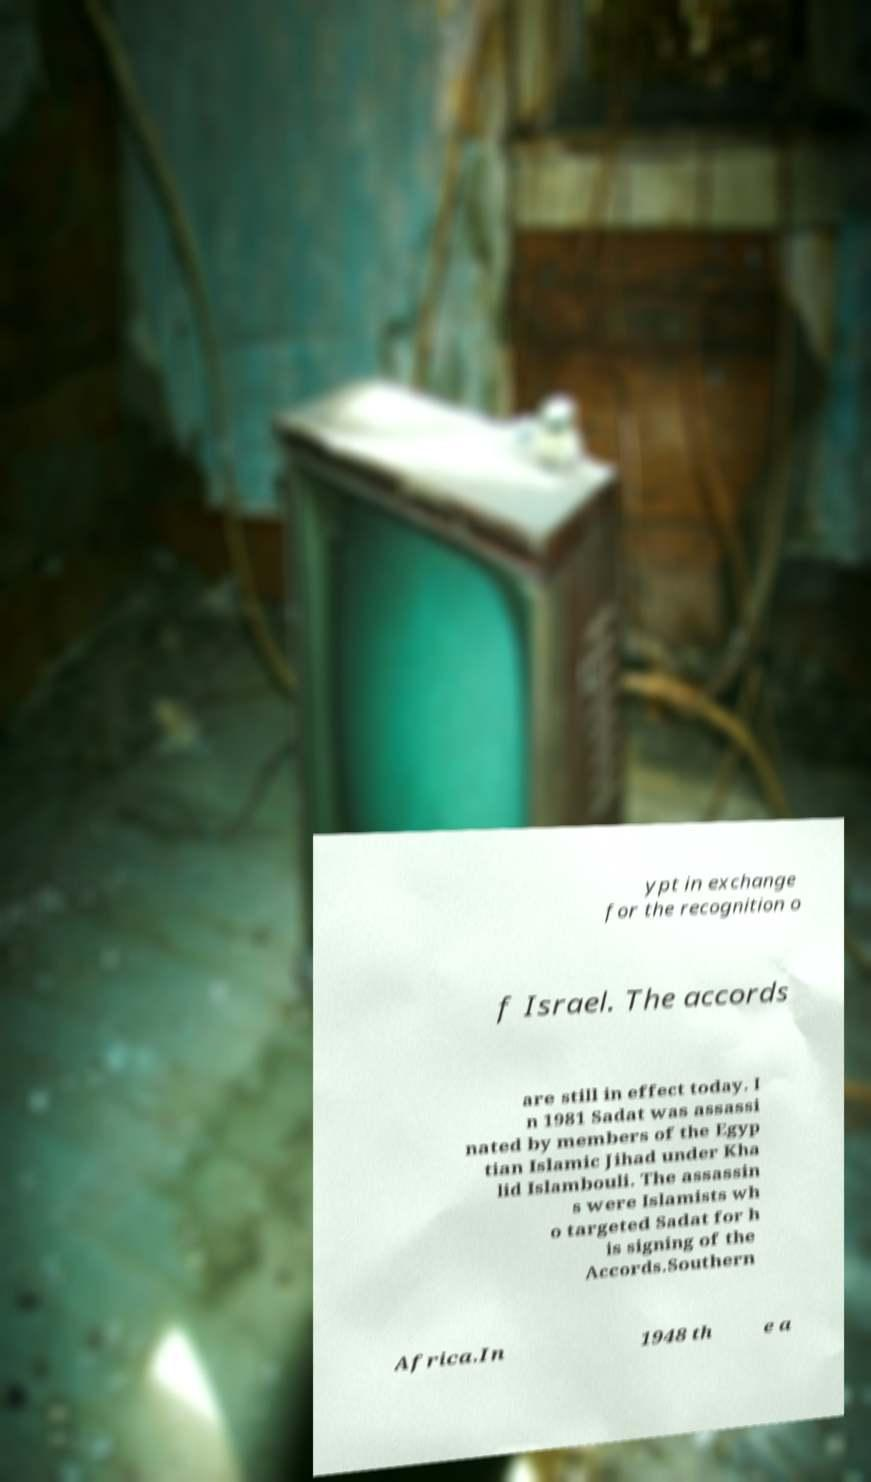Please identify and transcribe the text found in this image. ypt in exchange for the recognition o f Israel. The accords are still in effect today. I n 1981 Sadat was assassi nated by members of the Egyp tian Islamic Jihad under Kha lid Islambouli. The assassin s were Islamists wh o targeted Sadat for h is signing of the Accords.Southern Africa.In 1948 th e a 